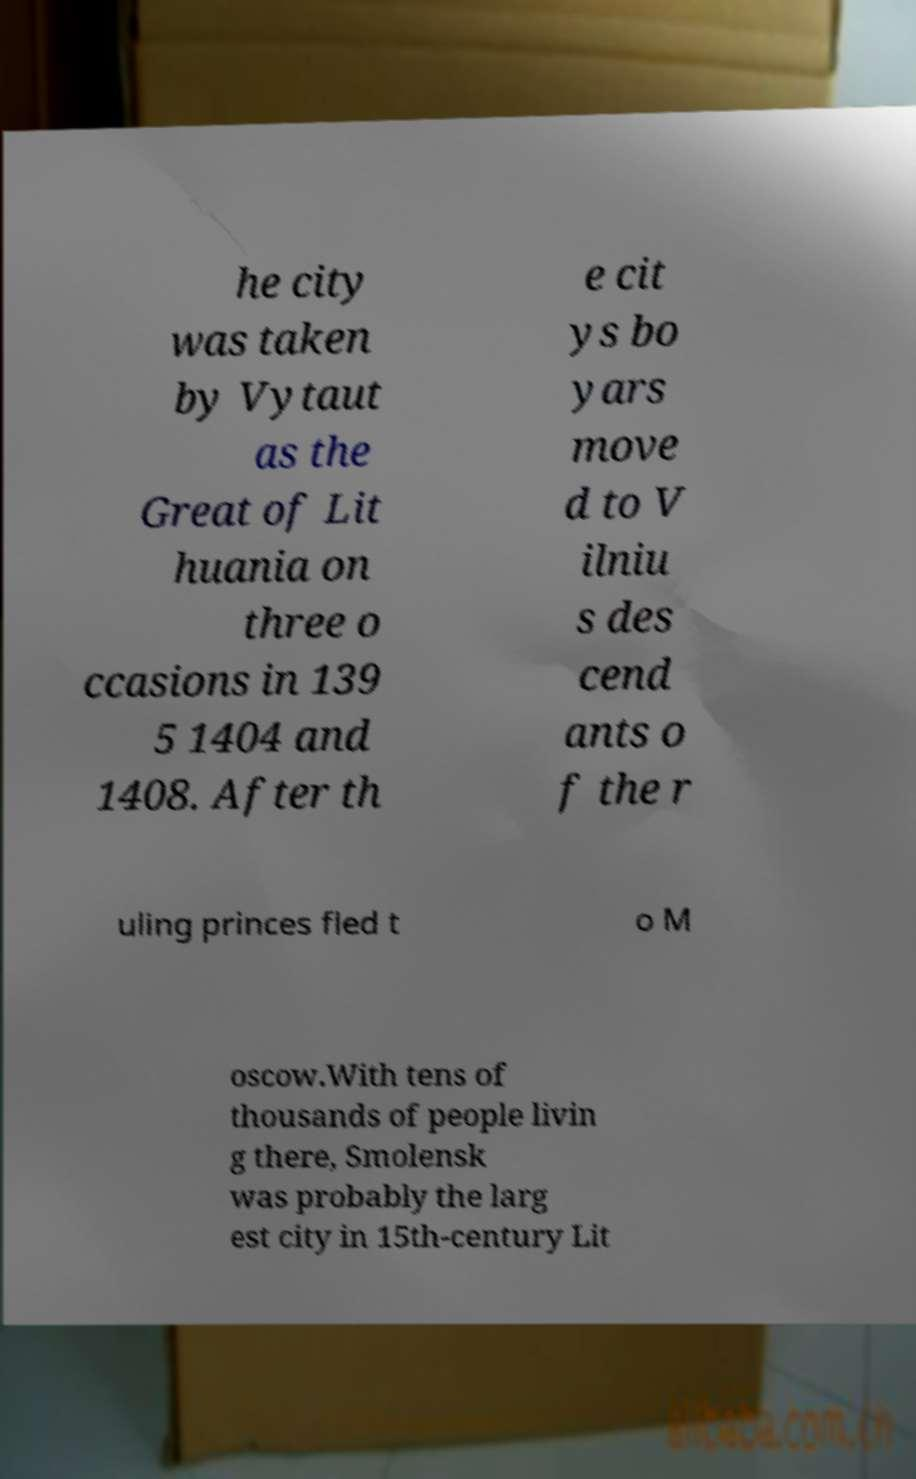For documentation purposes, I need the text within this image transcribed. Could you provide that? he city was taken by Vytaut as the Great of Lit huania on three o ccasions in 139 5 1404 and 1408. After th e cit ys bo yars move d to V ilniu s des cend ants o f the r uling princes fled t o M oscow.With tens of thousands of people livin g there, Smolensk was probably the larg est city in 15th-century Lit 